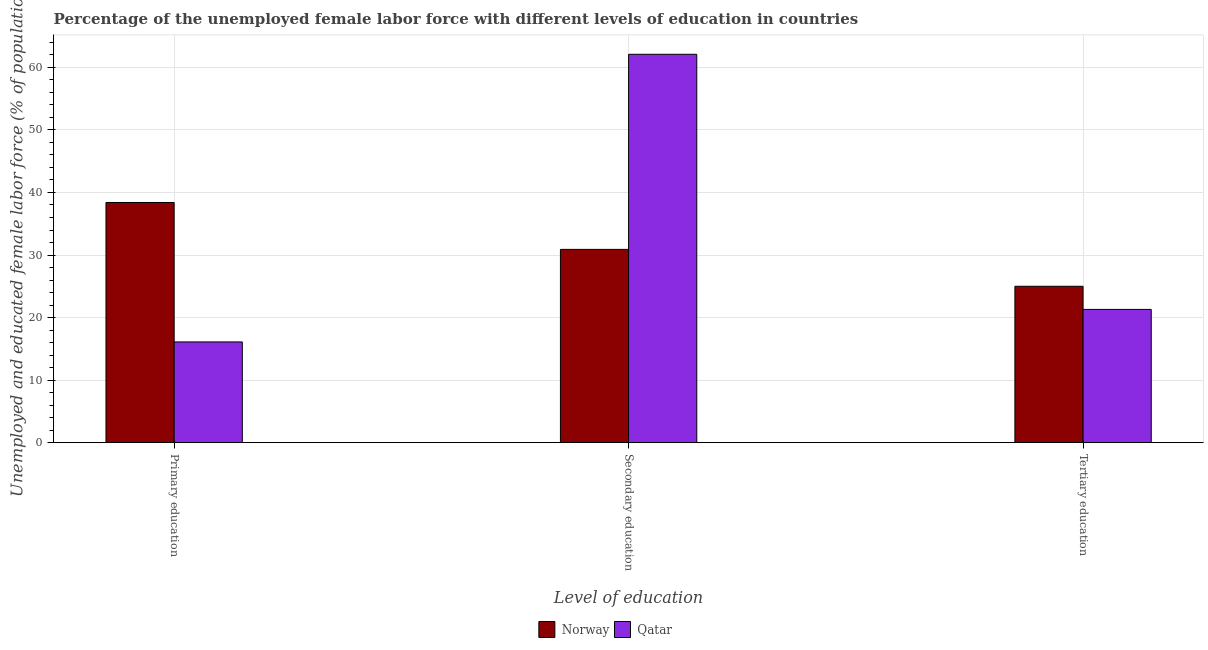How many different coloured bars are there?
Provide a succinct answer. 2. How many groups of bars are there?
Provide a short and direct response. 3. Are the number of bars per tick equal to the number of legend labels?
Keep it short and to the point. Yes. Are the number of bars on each tick of the X-axis equal?
Offer a very short reply. Yes. How many bars are there on the 3rd tick from the left?
Provide a short and direct response. 2. How many bars are there on the 1st tick from the right?
Provide a short and direct response. 2. What is the label of the 3rd group of bars from the left?
Make the answer very short. Tertiary education. What is the percentage of female labor force who received tertiary education in Norway?
Keep it short and to the point. 25. Across all countries, what is the maximum percentage of female labor force who received tertiary education?
Ensure brevity in your answer.  25. Across all countries, what is the minimum percentage of female labor force who received primary education?
Ensure brevity in your answer.  16.1. In which country was the percentage of female labor force who received tertiary education maximum?
Offer a very short reply. Norway. In which country was the percentage of female labor force who received tertiary education minimum?
Provide a short and direct response. Qatar. What is the total percentage of female labor force who received tertiary education in the graph?
Provide a succinct answer. 46.3. What is the difference between the percentage of female labor force who received primary education in Norway and that in Qatar?
Your answer should be compact. 22.3. What is the difference between the percentage of female labor force who received secondary education in Qatar and the percentage of female labor force who received primary education in Norway?
Give a very brief answer. 23.7. What is the average percentage of female labor force who received secondary education per country?
Offer a terse response. 46.5. What is the difference between the percentage of female labor force who received secondary education and percentage of female labor force who received primary education in Qatar?
Your answer should be compact. 46. In how many countries, is the percentage of female labor force who received primary education greater than 26 %?
Offer a terse response. 1. What is the ratio of the percentage of female labor force who received primary education in Qatar to that in Norway?
Ensure brevity in your answer.  0.42. Is the percentage of female labor force who received primary education in Norway less than that in Qatar?
Your answer should be compact. No. What is the difference between the highest and the second highest percentage of female labor force who received tertiary education?
Your answer should be compact. 3.7. What is the difference between the highest and the lowest percentage of female labor force who received primary education?
Offer a very short reply. 22.3. In how many countries, is the percentage of female labor force who received tertiary education greater than the average percentage of female labor force who received tertiary education taken over all countries?
Ensure brevity in your answer.  1. What does the 2nd bar from the left in Secondary education represents?
Give a very brief answer. Qatar. What does the 1st bar from the right in Primary education represents?
Offer a very short reply. Qatar. Are all the bars in the graph horizontal?
Your answer should be very brief. No. How many countries are there in the graph?
Your response must be concise. 2. Does the graph contain grids?
Offer a very short reply. Yes. Where does the legend appear in the graph?
Your response must be concise. Bottom center. How many legend labels are there?
Make the answer very short. 2. What is the title of the graph?
Provide a short and direct response. Percentage of the unemployed female labor force with different levels of education in countries. Does "Uganda" appear as one of the legend labels in the graph?
Provide a succinct answer. No. What is the label or title of the X-axis?
Provide a short and direct response. Level of education. What is the label or title of the Y-axis?
Keep it short and to the point. Unemployed and educated female labor force (% of population). What is the Unemployed and educated female labor force (% of population) of Norway in Primary education?
Give a very brief answer. 38.4. What is the Unemployed and educated female labor force (% of population) in Qatar in Primary education?
Offer a terse response. 16.1. What is the Unemployed and educated female labor force (% of population) of Norway in Secondary education?
Your response must be concise. 30.9. What is the Unemployed and educated female labor force (% of population) in Qatar in Secondary education?
Give a very brief answer. 62.1. What is the Unemployed and educated female labor force (% of population) of Norway in Tertiary education?
Provide a succinct answer. 25. What is the Unemployed and educated female labor force (% of population) in Qatar in Tertiary education?
Your answer should be very brief. 21.3. Across all Level of education, what is the maximum Unemployed and educated female labor force (% of population) in Norway?
Offer a very short reply. 38.4. Across all Level of education, what is the maximum Unemployed and educated female labor force (% of population) in Qatar?
Ensure brevity in your answer.  62.1. Across all Level of education, what is the minimum Unemployed and educated female labor force (% of population) in Norway?
Provide a succinct answer. 25. Across all Level of education, what is the minimum Unemployed and educated female labor force (% of population) in Qatar?
Offer a very short reply. 16.1. What is the total Unemployed and educated female labor force (% of population) in Norway in the graph?
Your response must be concise. 94.3. What is the total Unemployed and educated female labor force (% of population) in Qatar in the graph?
Keep it short and to the point. 99.5. What is the difference between the Unemployed and educated female labor force (% of population) in Qatar in Primary education and that in Secondary education?
Your answer should be very brief. -46. What is the difference between the Unemployed and educated female labor force (% of population) of Norway in Secondary education and that in Tertiary education?
Offer a terse response. 5.9. What is the difference between the Unemployed and educated female labor force (% of population) in Qatar in Secondary education and that in Tertiary education?
Offer a terse response. 40.8. What is the difference between the Unemployed and educated female labor force (% of population) in Norway in Primary education and the Unemployed and educated female labor force (% of population) in Qatar in Secondary education?
Provide a succinct answer. -23.7. What is the average Unemployed and educated female labor force (% of population) of Norway per Level of education?
Provide a short and direct response. 31.43. What is the average Unemployed and educated female labor force (% of population) of Qatar per Level of education?
Your response must be concise. 33.17. What is the difference between the Unemployed and educated female labor force (% of population) of Norway and Unemployed and educated female labor force (% of population) of Qatar in Primary education?
Your response must be concise. 22.3. What is the difference between the Unemployed and educated female labor force (% of population) of Norway and Unemployed and educated female labor force (% of population) of Qatar in Secondary education?
Provide a short and direct response. -31.2. What is the difference between the Unemployed and educated female labor force (% of population) in Norway and Unemployed and educated female labor force (% of population) in Qatar in Tertiary education?
Offer a terse response. 3.7. What is the ratio of the Unemployed and educated female labor force (% of population) of Norway in Primary education to that in Secondary education?
Offer a terse response. 1.24. What is the ratio of the Unemployed and educated female labor force (% of population) of Qatar in Primary education to that in Secondary education?
Provide a succinct answer. 0.26. What is the ratio of the Unemployed and educated female labor force (% of population) of Norway in Primary education to that in Tertiary education?
Give a very brief answer. 1.54. What is the ratio of the Unemployed and educated female labor force (% of population) of Qatar in Primary education to that in Tertiary education?
Your response must be concise. 0.76. What is the ratio of the Unemployed and educated female labor force (% of population) in Norway in Secondary education to that in Tertiary education?
Make the answer very short. 1.24. What is the ratio of the Unemployed and educated female labor force (% of population) in Qatar in Secondary education to that in Tertiary education?
Offer a terse response. 2.92. What is the difference between the highest and the second highest Unemployed and educated female labor force (% of population) in Qatar?
Ensure brevity in your answer.  40.8. 